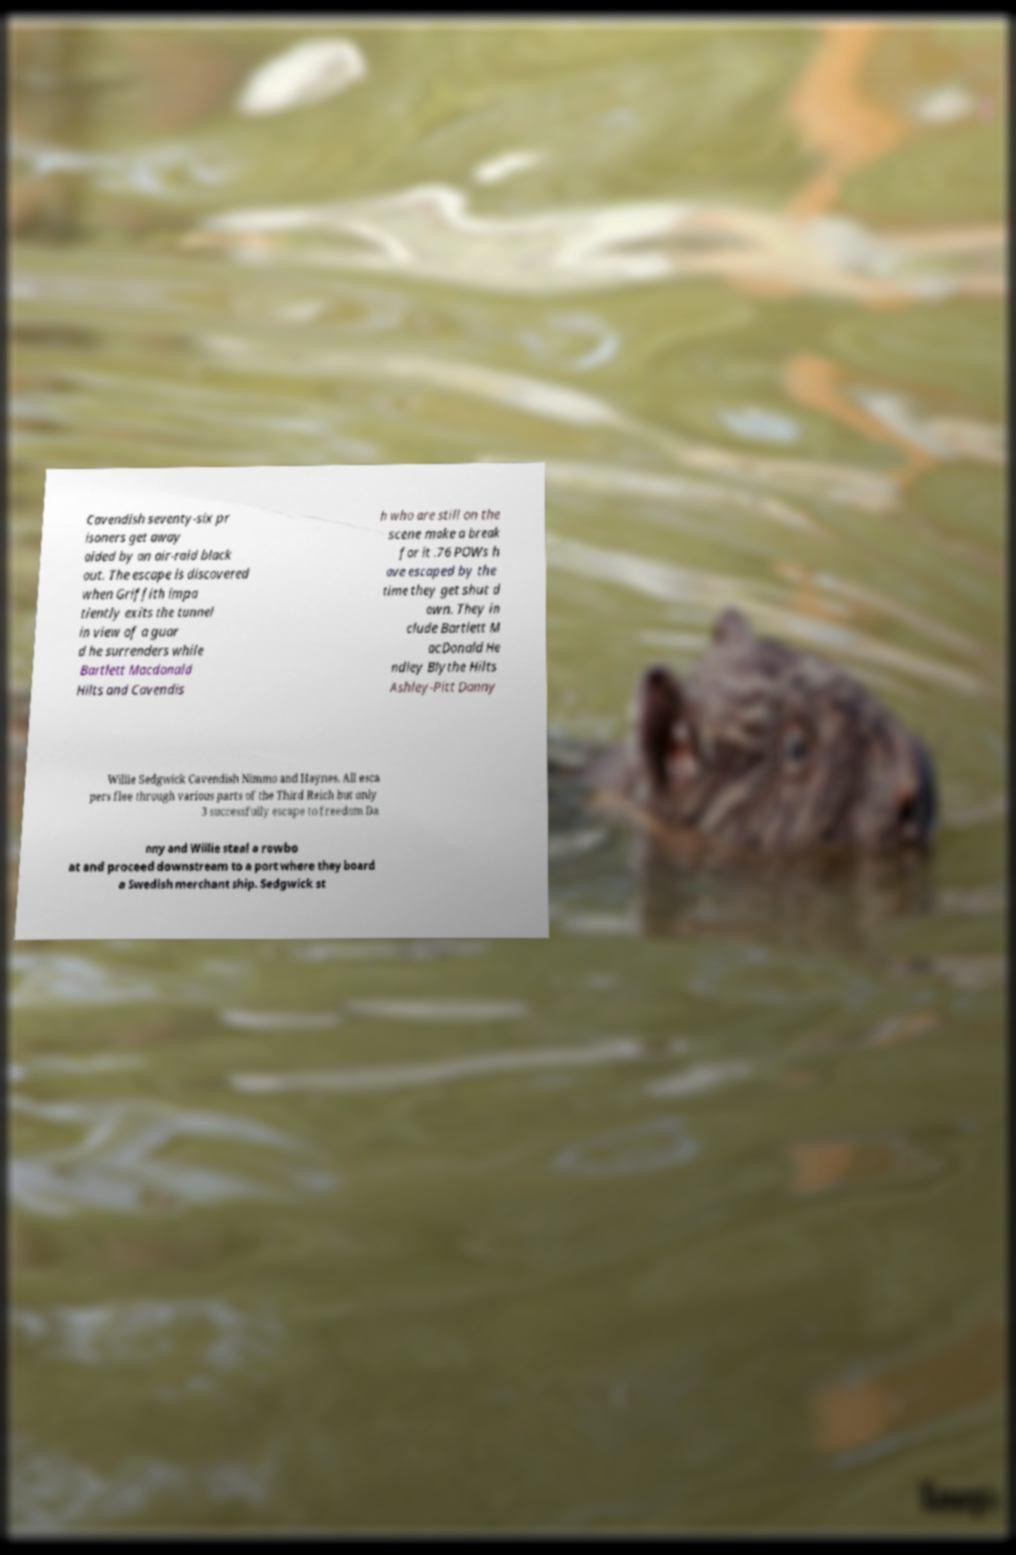Can you read and provide the text displayed in the image?This photo seems to have some interesting text. Can you extract and type it out for me? Cavendish seventy-six pr isoners get away aided by an air-raid black out. The escape is discovered when Griffith impa tiently exits the tunnel in view of a guar d he surrenders while Bartlett Macdonald Hilts and Cavendis h who are still on the scene make a break for it .76 POWs h ave escaped by the time they get shut d own. They in clude Bartlett M acDonald He ndley Blythe Hilts Ashley-Pitt Danny Willie Sedgwick Cavendish Nimmo and Haynes. All esca pers flee through various parts of the Third Reich but only 3 successfully escape to freedom Da nny and Willie steal a rowbo at and proceed downstream to a port where they board a Swedish merchant ship. Sedgwick st 